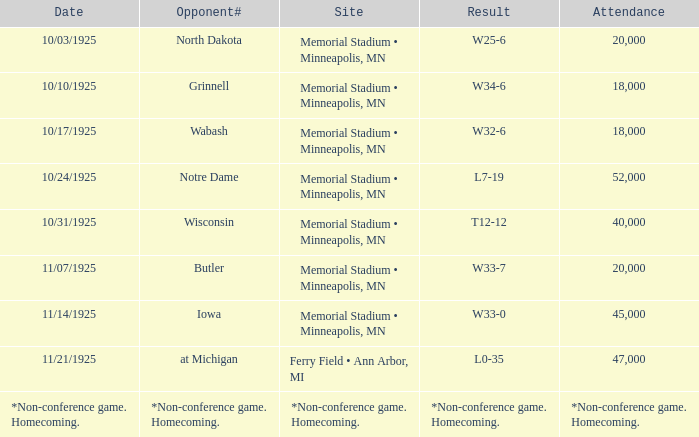Who was the competitor at the event attended by 45,000? Iowa. 